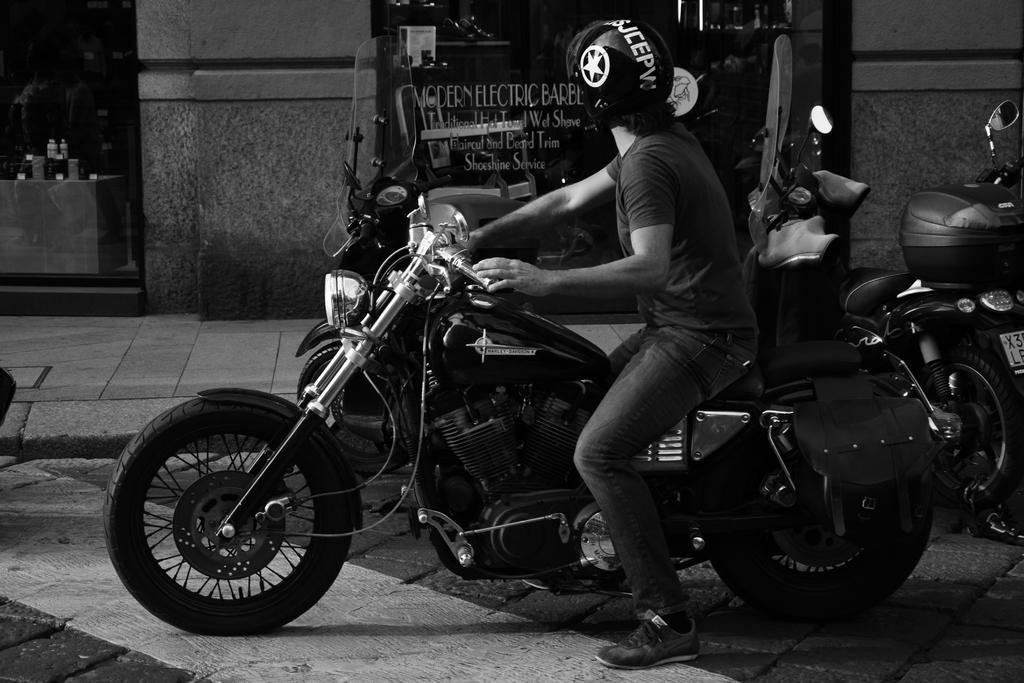Could you give a brief overview of what you see in this image? In this image there is a person sitting on a bike wearing a helmet and the right side of image there are bikes on the road. There is a pavement beside it. Few bottles are there on table at the left side of the image. 